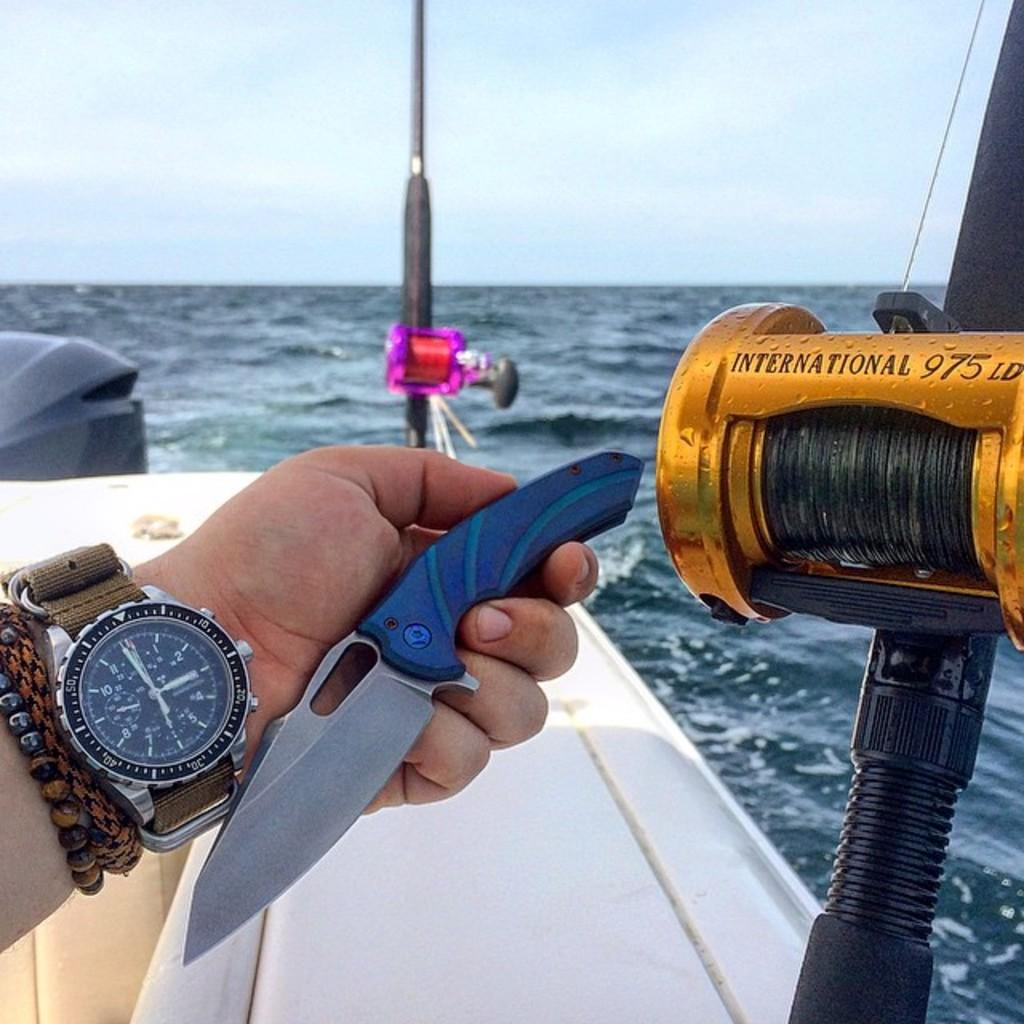<image>
Offer a succinct explanation of the picture presented. Person holding a knife next to a yellow vehicle that says "International" on it. 